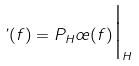Convert formula to latex. <formula><loc_0><loc_0><loc_500><loc_500>\varphi ( f ) = P _ { H } \sigma ( f ) \Big | _ { H }</formula> 